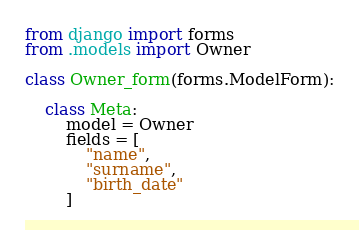<code> <loc_0><loc_0><loc_500><loc_500><_Python_>from django import forms
from .models import Owner

class Owner_form(forms.ModelForm):

    class Meta:
        model = Owner
        fields = [
            "name",
            "surname",
            "birth_date"
        ]</code> 